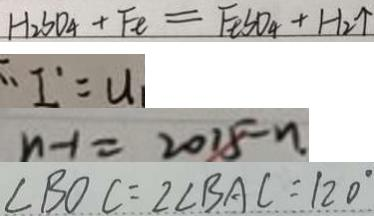Convert formula to latex. <formula><loc_0><loc_0><loc_500><loc_500>H _ { 2 } S O _ { 4 } + F e = F e S O _ { 4 } + H _ { 2 } \uparrow 
 \therefore I ^ { \prime } = u 
 n - 1 = 2 0 1 5 - n 
 \angle B O C = 2 \angle B A C = 1 2 0 ^ { \circ }</formula> 